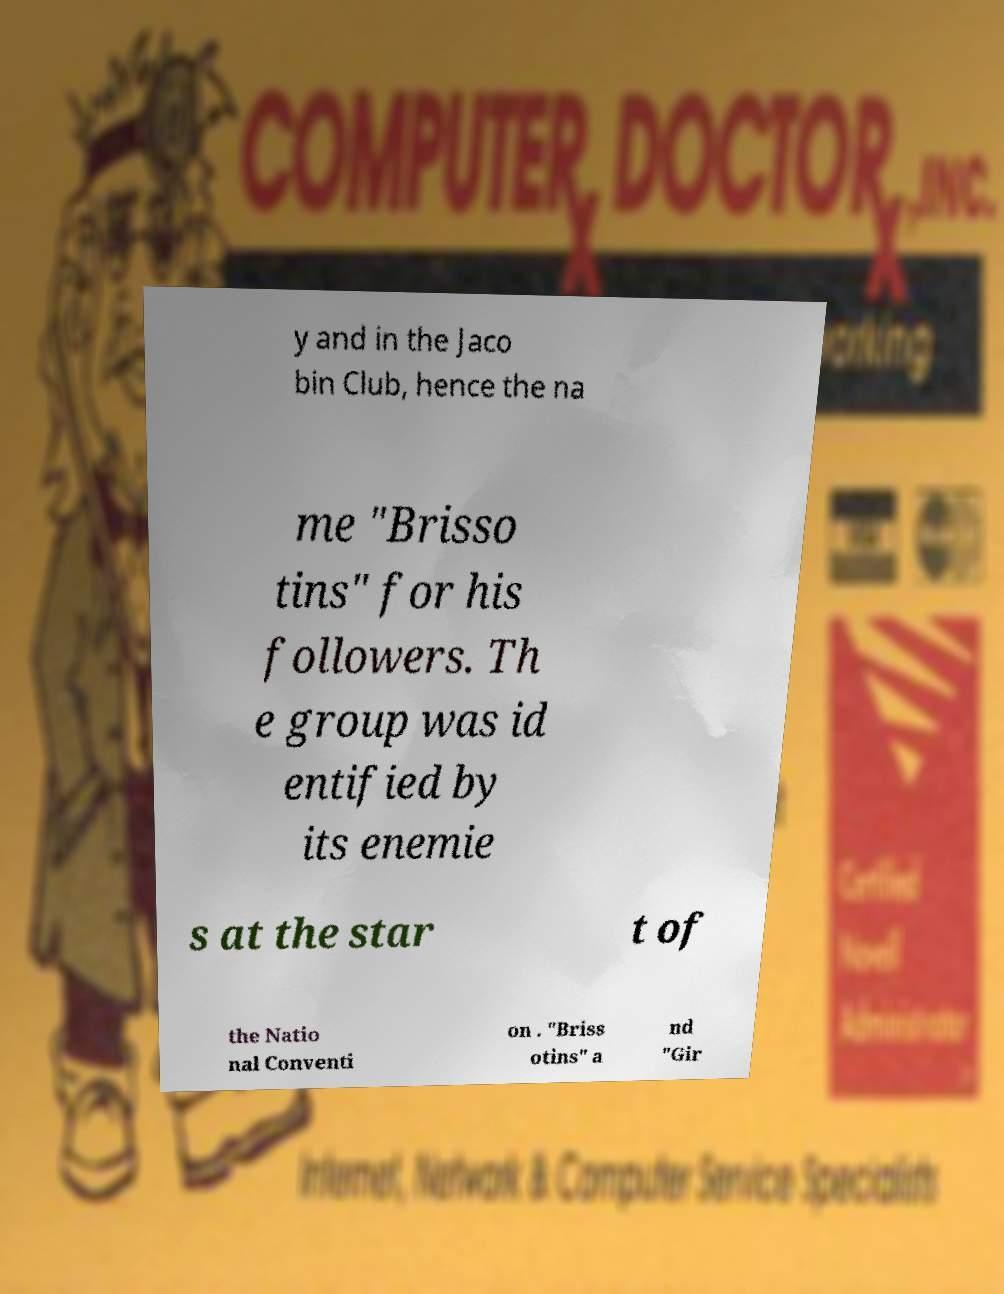What messages or text are displayed in this image? I need them in a readable, typed format. y and in the Jaco bin Club, hence the na me "Brisso tins" for his followers. Th e group was id entified by its enemie s at the star t of the Natio nal Conventi on . "Briss otins" a nd "Gir 